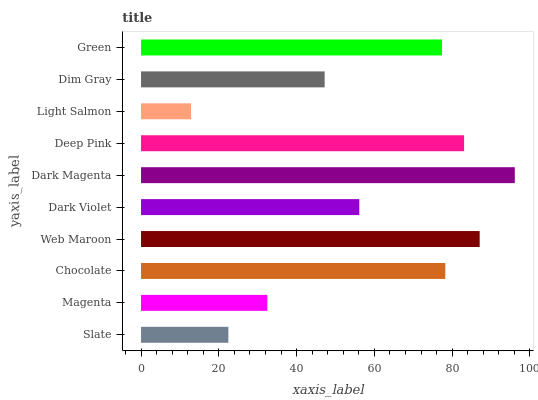Is Light Salmon the minimum?
Answer yes or no. Yes. Is Dark Magenta the maximum?
Answer yes or no. Yes. Is Magenta the minimum?
Answer yes or no. No. Is Magenta the maximum?
Answer yes or no. No. Is Magenta greater than Slate?
Answer yes or no. Yes. Is Slate less than Magenta?
Answer yes or no. Yes. Is Slate greater than Magenta?
Answer yes or no. No. Is Magenta less than Slate?
Answer yes or no. No. Is Green the high median?
Answer yes or no. Yes. Is Dark Violet the low median?
Answer yes or no. Yes. Is Dim Gray the high median?
Answer yes or no. No. Is Dark Magenta the low median?
Answer yes or no. No. 